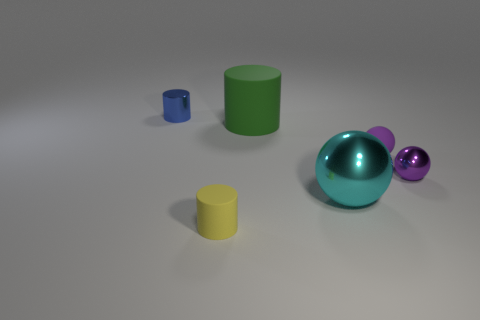Add 4 small matte spheres. How many objects exist? 10 Add 3 gray metal blocks. How many gray metal blocks exist? 3 Subtract 0 green balls. How many objects are left? 6 Subtract all gray objects. Subtract all small shiny balls. How many objects are left? 5 Add 2 yellow rubber things. How many yellow rubber things are left? 3 